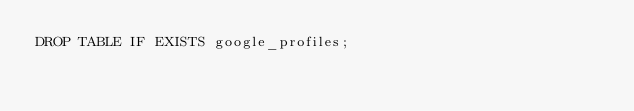<code> <loc_0><loc_0><loc_500><loc_500><_SQL_>DROP TABLE IF EXISTS google_profiles;
</code> 